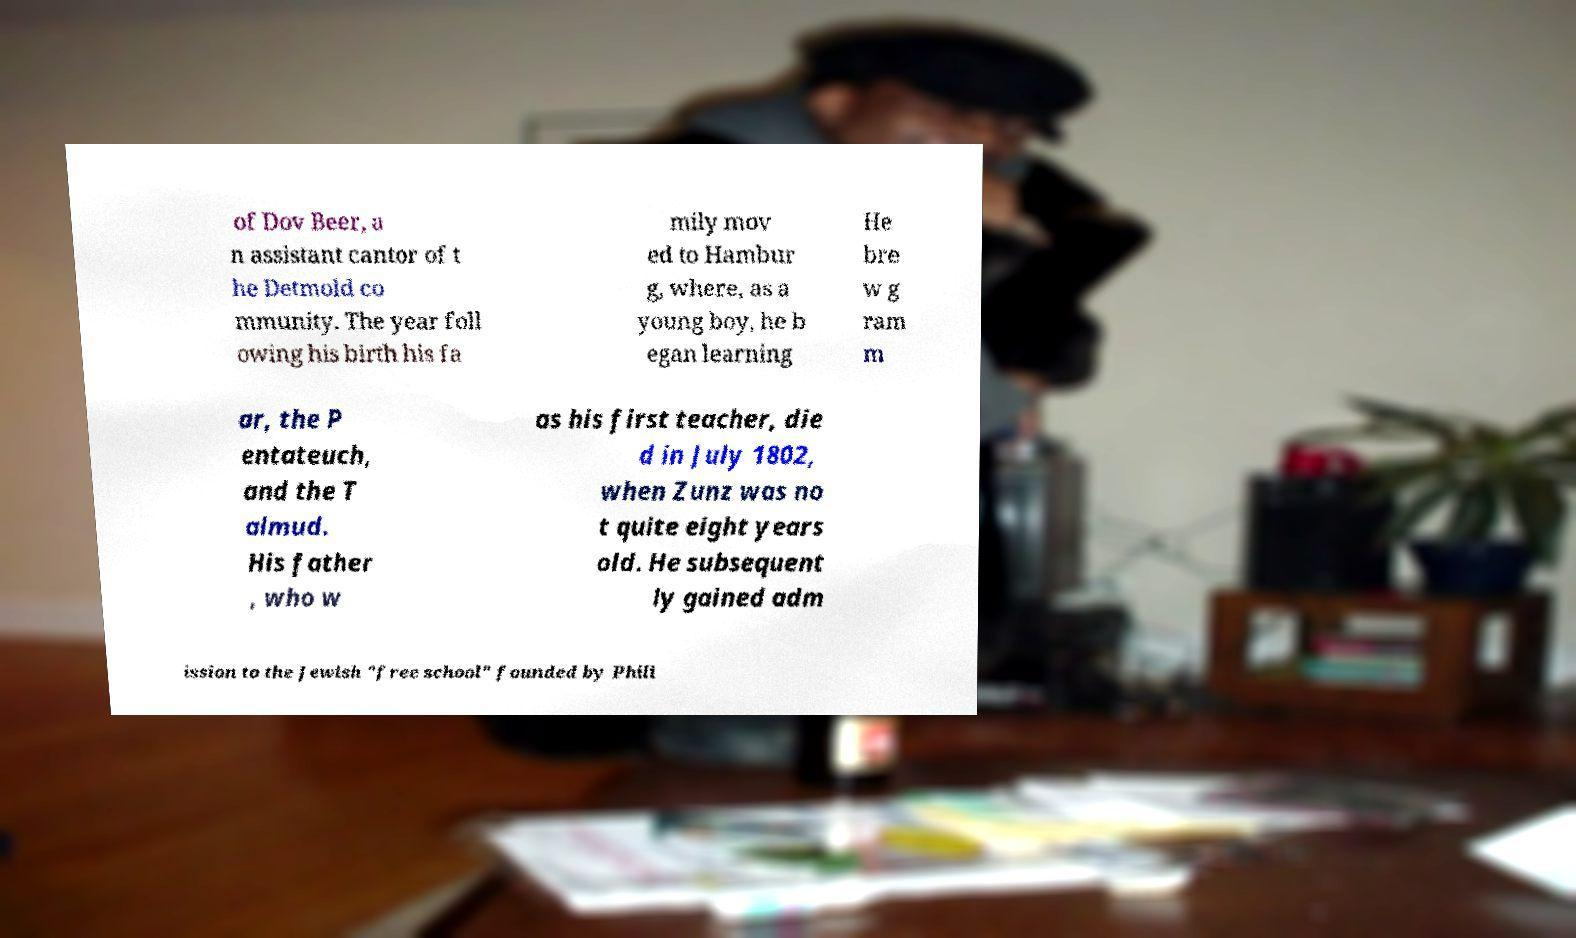Could you extract and type out the text from this image? of Dov Beer, a n assistant cantor of t he Detmold co mmunity. The year foll owing his birth his fa mily mov ed to Hambur g, where, as a young boy, he b egan learning He bre w g ram m ar, the P entateuch, and the T almud. His father , who w as his first teacher, die d in July 1802, when Zunz was no t quite eight years old. He subsequent ly gained adm ission to the Jewish "free school" founded by Phili 